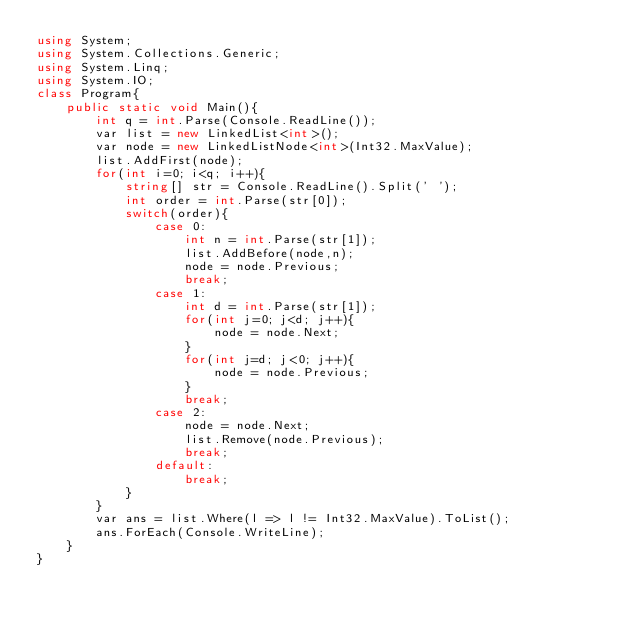Convert code to text. <code><loc_0><loc_0><loc_500><loc_500><_C#_>using System;
using System.Collections.Generic;
using System.Linq;
using System.IO;
class Program{
    public static void Main(){
        int q = int.Parse(Console.ReadLine());
        var list = new LinkedList<int>();
        var node = new LinkedListNode<int>(Int32.MaxValue);
        list.AddFirst(node);
        for(int i=0; i<q; i++){
            string[] str = Console.ReadLine().Split(' ');
            int order = int.Parse(str[0]);
            switch(order){
                case 0:
                    int n = int.Parse(str[1]);
                    list.AddBefore(node,n);
                    node = node.Previous;
                    break;
                case 1:
                    int d = int.Parse(str[1]);
                    for(int j=0; j<d; j++){
                        node = node.Next;
                    }
                    for(int j=d; j<0; j++){
                        node = node.Previous;
                    }
                    break;
                case 2:
                    node = node.Next;
                    list.Remove(node.Previous);
                    break;
                default:
                    break;
            }
        }
        var ans = list.Where(l => l != Int32.MaxValue).ToList();
        ans.ForEach(Console.WriteLine);
    }
}

</code> 